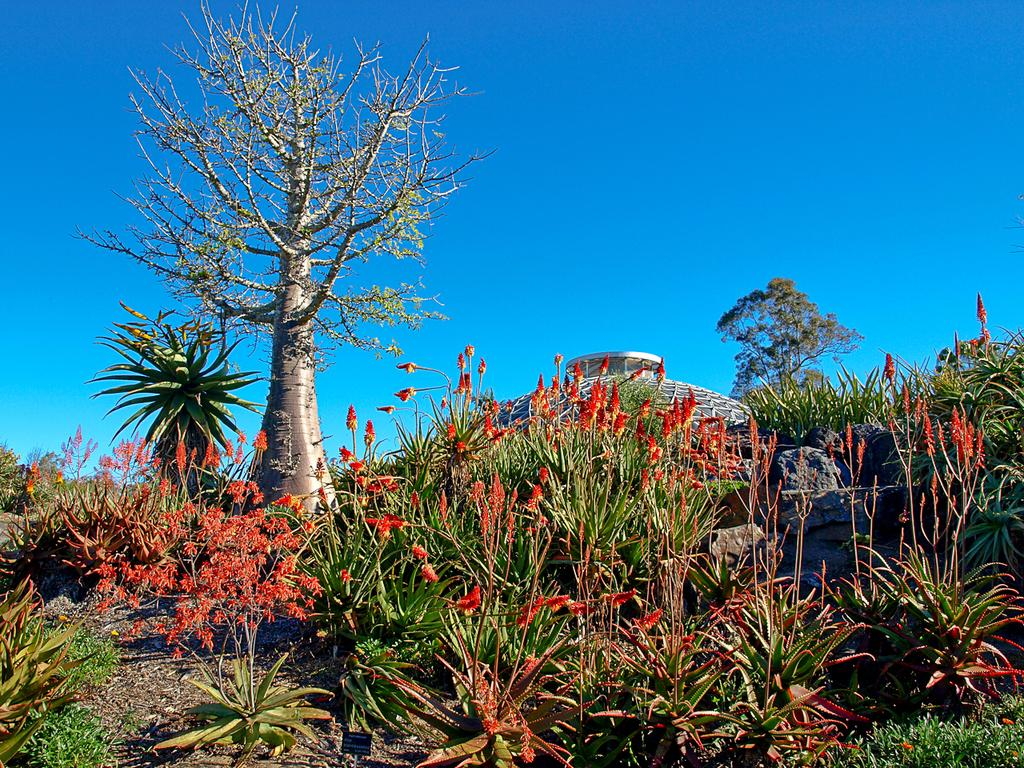What is the main structure in the image? There is a monument in the image. What type of natural elements can be seen in the image? There are trees in the image. What type of vegetation is present at the bottom of the image? There are flowers on plants at the bottom of the image. What is visible at the top of the image? The sky is visible at the top of the image. How many hats can be seen on the flock of birds in the image? There are no birds or hats present in the image. 